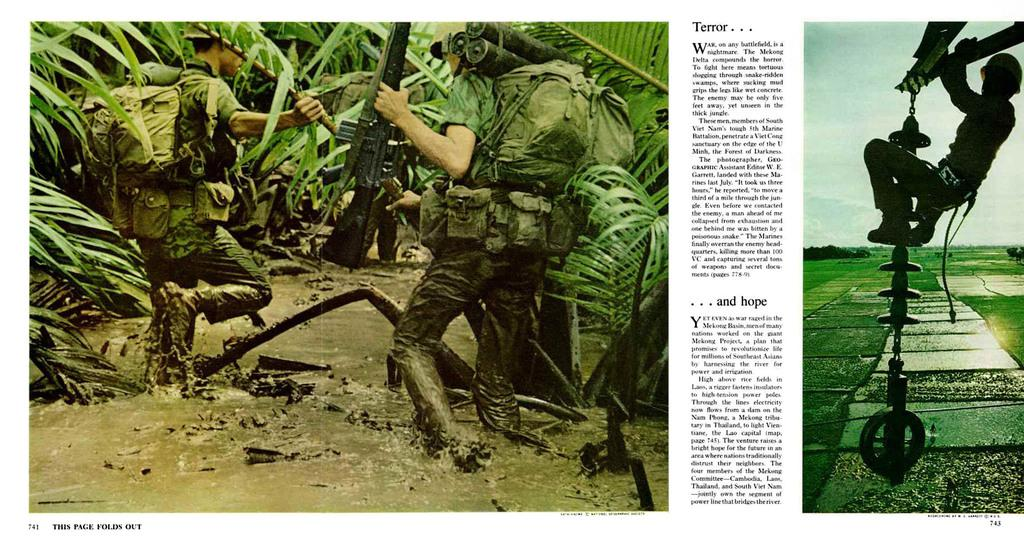Who or what can be seen in the image? There are people in the image. What type of natural elements are present in the image? There are trees in the image. What part of the environment is visible in the image? The sky is visible in the image. Can you describe any other elements in the image? There are other unspecified elements in the image. Is there any text or writing in the image? Yes, there is something written on the image. How many geese are swimming in the basin in the image? There are no geese or basin present in the image. What type of cork is used to seal the bottle in the image? There is no bottle or cork present in the image. 